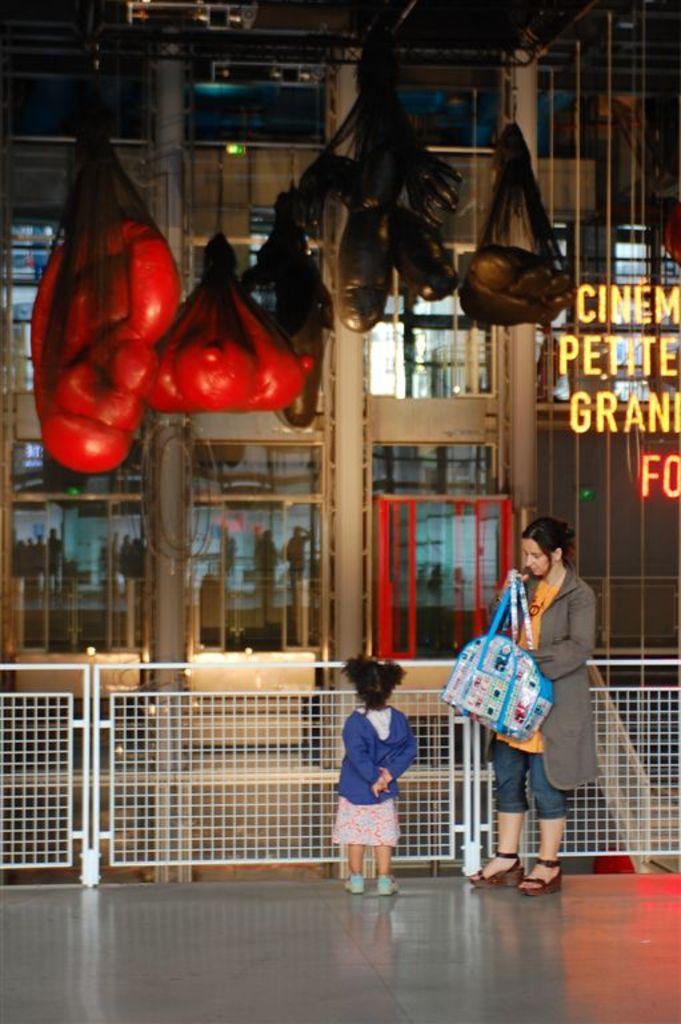Please provide a concise description of this image. In the center of the image we can see a girl is standing and wearing hoodie. On the right side of the image we can see a lady is standing and wearing coat and holding a bag. In the background of the image we can see the bags, pillars, wall, text and some persons. In the center of the image we can see the railing. At the bottom of the image we can see the floor. At the top of the image we can see the roof and rods. 